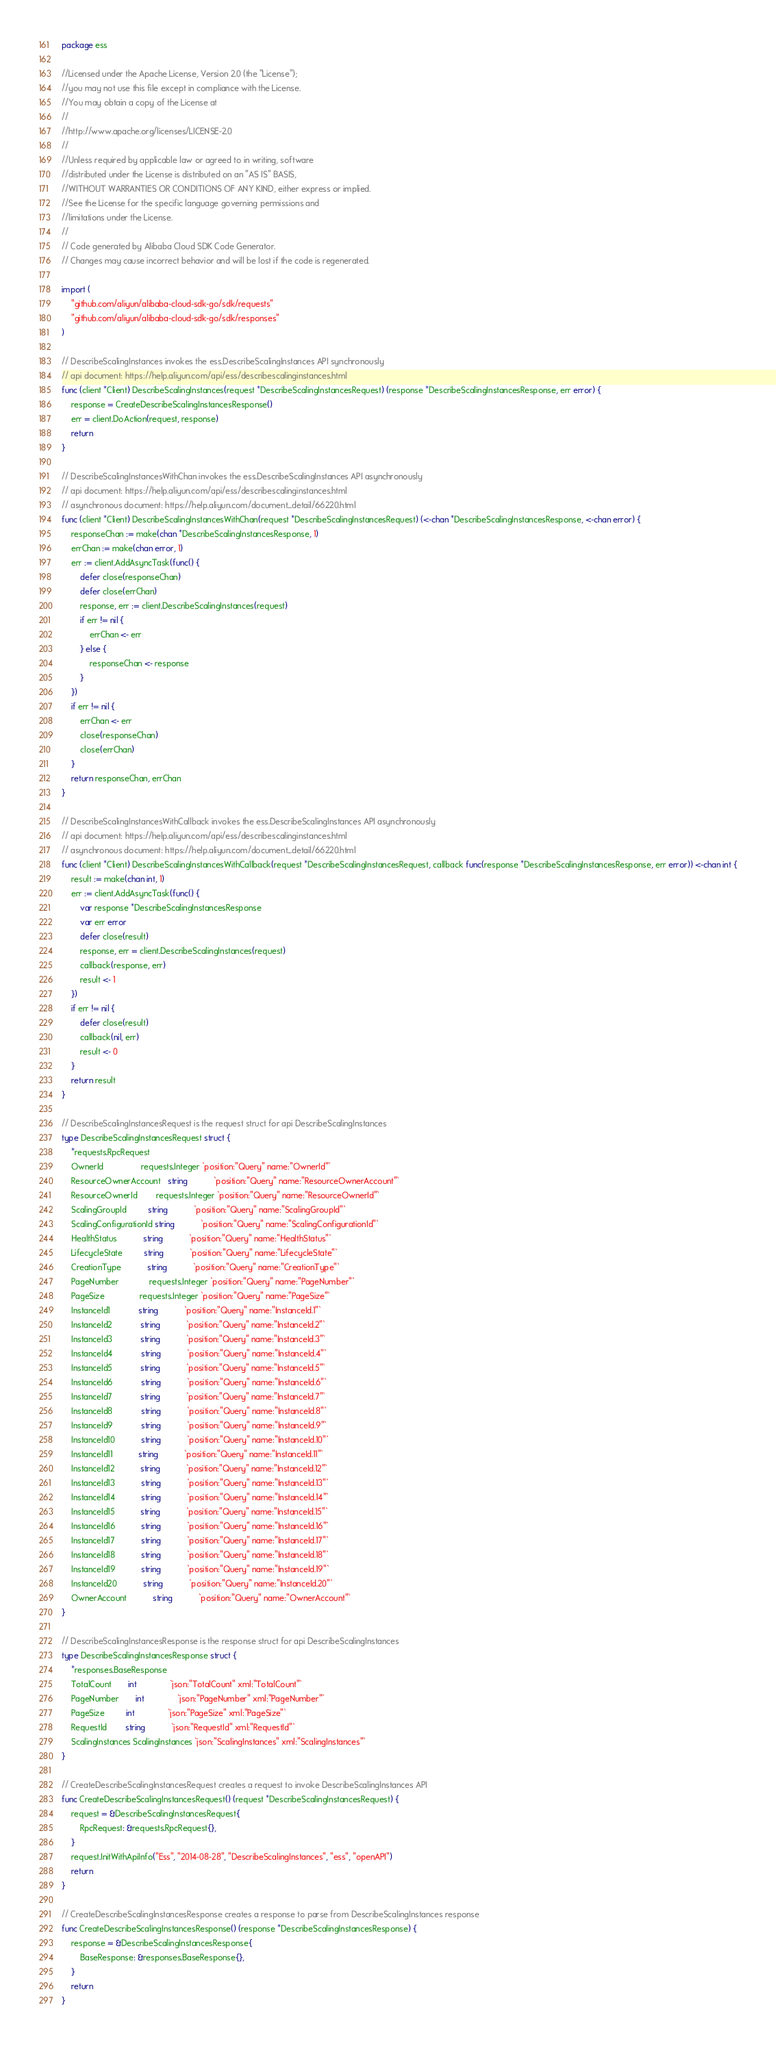Convert code to text. <code><loc_0><loc_0><loc_500><loc_500><_Go_>package ess

//Licensed under the Apache License, Version 2.0 (the "License");
//you may not use this file except in compliance with the License.
//You may obtain a copy of the License at
//
//http://www.apache.org/licenses/LICENSE-2.0
//
//Unless required by applicable law or agreed to in writing, software
//distributed under the License is distributed on an "AS IS" BASIS,
//WITHOUT WARRANTIES OR CONDITIONS OF ANY KIND, either express or implied.
//See the License for the specific language governing permissions and
//limitations under the License.
//
// Code generated by Alibaba Cloud SDK Code Generator.
// Changes may cause incorrect behavior and will be lost if the code is regenerated.

import (
	"github.com/aliyun/alibaba-cloud-sdk-go/sdk/requests"
	"github.com/aliyun/alibaba-cloud-sdk-go/sdk/responses"
)

// DescribeScalingInstances invokes the ess.DescribeScalingInstances API synchronously
// api document: https://help.aliyun.com/api/ess/describescalinginstances.html
func (client *Client) DescribeScalingInstances(request *DescribeScalingInstancesRequest) (response *DescribeScalingInstancesResponse, err error) {
	response = CreateDescribeScalingInstancesResponse()
	err = client.DoAction(request, response)
	return
}

// DescribeScalingInstancesWithChan invokes the ess.DescribeScalingInstances API asynchronously
// api document: https://help.aliyun.com/api/ess/describescalinginstances.html
// asynchronous document: https://help.aliyun.com/document_detail/66220.html
func (client *Client) DescribeScalingInstancesWithChan(request *DescribeScalingInstancesRequest) (<-chan *DescribeScalingInstancesResponse, <-chan error) {
	responseChan := make(chan *DescribeScalingInstancesResponse, 1)
	errChan := make(chan error, 1)
	err := client.AddAsyncTask(func() {
		defer close(responseChan)
		defer close(errChan)
		response, err := client.DescribeScalingInstances(request)
		if err != nil {
			errChan <- err
		} else {
			responseChan <- response
		}
	})
	if err != nil {
		errChan <- err
		close(responseChan)
		close(errChan)
	}
	return responseChan, errChan
}

// DescribeScalingInstancesWithCallback invokes the ess.DescribeScalingInstances API asynchronously
// api document: https://help.aliyun.com/api/ess/describescalinginstances.html
// asynchronous document: https://help.aliyun.com/document_detail/66220.html
func (client *Client) DescribeScalingInstancesWithCallback(request *DescribeScalingInstancesRequest, callback func(response *DescribeScalingInstancesResponse, err error)) <-chan int {
	result := make(chan int, 1)
	err := client.AddAsyncTask(func() {
		var response *DescribeScalingInstancesResponse
		var err error
		defer close(result)
		response, err = client.DescribeScalingInstances(request)
		callback(response, err)
		result <- 1
	})
	if err != nil {
		defer close(result)
		callback(nil, err)
		result <- 0
	}
	return result
}

// DescribeScalingInstancesRequest is the request struct for api DescribeScalingInstances
type DescribeScalingInstancesRequest struct {
	*requests.RpcRequest
	OwnerId                requests.Integer `position:"Query" name:"OwnerId"`
	ResourceOwnerAccount   string           `position:"Query" name:"ResourceOwnerAccount"`
	ResourceOwnerId        requests.Integer `position:"Query" name:"ResourceOwnerId"`
	ScalingGroupId         string           `position:"Query" name:"ScalingGroupId"`
	ScalingConfigurationId string           `position:"Query" name:"ScalingConfigurationId"`
	HealthStatus           string           `position:"Query" name:"HealthStatus"`
	LifecycleState         string           `position:"Query" name:"LifecycleState"`
	CreationType           string           `position:"Query" name:"CreationType"`
	PageNumber             requests.Integer `position:"Query" name:"PageNumber"`
	PageSize               requests.Integer `position:"Query" name:"PageSize"`
	InstanceId1            string           `position:"Query" name:"InstanceId.1"`
	InstanceId2            string           `position:"Query" name:"InstanceId.2"`
	InstanceId3            string           `position:"Query" name:"InstanceId.3"`
	InstanceId4            string           `position:"Query" name:"InstanceId.4"`
	InstanceId5            string           `position:"Query" name:"InstanceId.5"`
	InstanceId6            string           `position:"Query" name:"InstanceId.6"`
	InstanceId7            string           `position:"Query" name:"InstanceId.7"`
	InstanceId8            string           `position:"Query" name:"InstanceId.8"`
	InstanceId9            string           `position:"Query" name:"InstanceId.9"`
	InstanceId10           string           `position:"Query" name:"InstanceId.10"`
	InstanceId11           string           `position:"Query" name:"InstanceId.11"`
	InstanceId12           string           `position:"Query" name:"InstanceId.12"`
	InstanceId13           string           `position:"Query" name:"InstanceId.13"`
	InstanceId14           string           `position:"Query" name:"InstanceId.14"`
	InstanceId15           string           `position:"Query" name:"InstanceId.15"`
	InstanceId16           string           `position:"Query" name:"InstanceId.16"`
	InstanceId17           string           `position:"Query" name:"InstanceId.17"`
	InstanceId18           string           `position:"Query" name:"InstanceId.18"`
	InstanceId19           string           `position:"Query" name:"InstanceId.19"`
	InstanceId20           string           `position:"Query" name:"InstanceId.20"`
	OwnerAccount           string           `position:"Query" name:"OwnerAccount"`
}

// DescribeScalingInstancesResponse is the response struct for api DescribeScalingInstances
type DescribeScalingInstancesResponse struct {
	*responses.BaseResponse
	TotalCount       int              `json:"TotalCount" xml:"TotalCount"`
	PageNumber       int              `json:"PageNumber" xml:"PageNumber"`
	PageSize         int              `json:"PageSize" xml:"PageSize"`
	RequestId        string           `json:"RequestId" xml:"RequestId"`
	ScalingInstances ScalingInstances `json:"ScalingInstances" xml:"ScalingInstances"`
}

// CreateDescribeScalingInstancesRequest creates a request to invoke DescribeScalingInstances API
func CreateDescribeScalingInstancesRequest() (request *DescribeScalingInstancesRequest) {
	request = &DescribeScalingInstancesRequest{
		RpcRequest: &requests.RpcRequest{},
	}
	request.InitWithApiInfo("Ess", "2014-08-28", "DescribeScalingInstances", "ess", "openAPI")
	return
}

// CreateDescribeScalingInstancesResponse creates a response to parse from DescribeScalingInstances response
func CreateDescribeScalingInstancesResponse() (response *DescribeScalingInstancesResponse) {
	response = &DescribeScalingInstancesResponse{
		BaseResponse: &responses.BaseResponse{},
	}
	return
}
</code> 